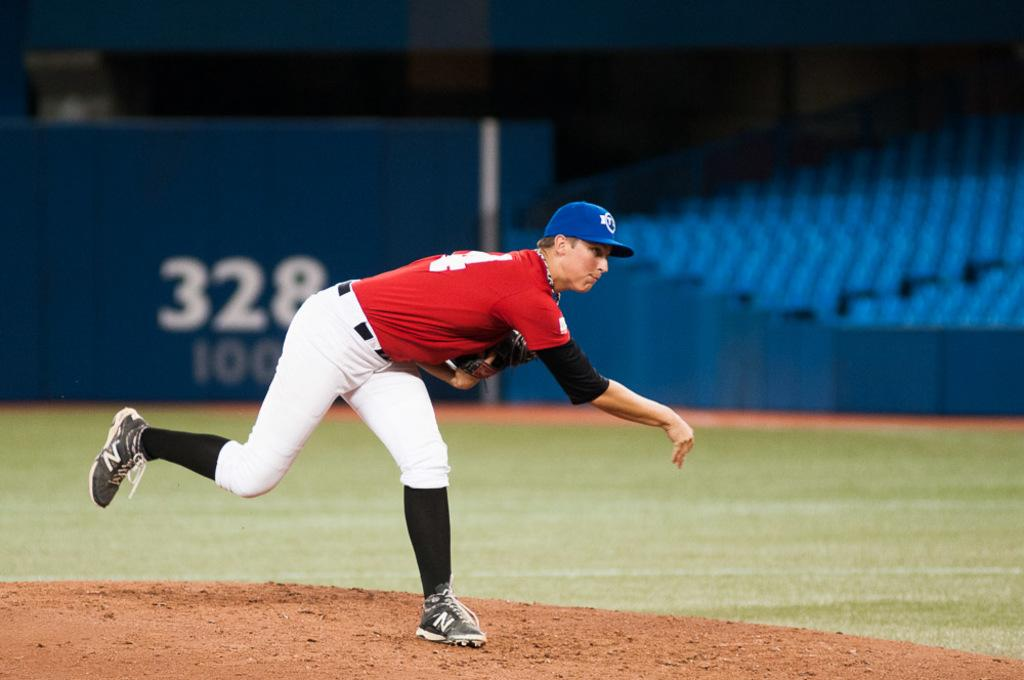Provide a one-sentence caption for the provided image. Professional baseball pitcher having just thrown the ball from the pitcher's mound. 